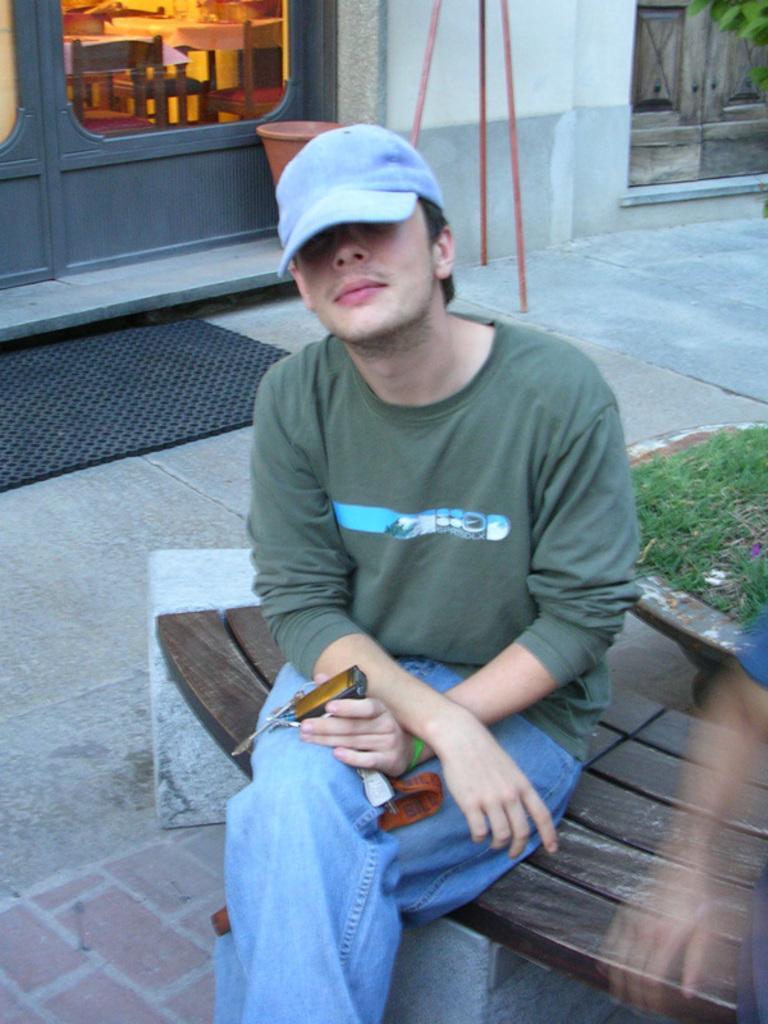Can you describe this image briefly? In this image we can see two persons sitting on the bench. One person is wearing a cap and holding a device in his hand. In the background, we can see grass in a pot, a stand, a group of chairs, tables, doors and a mat on the ground. 